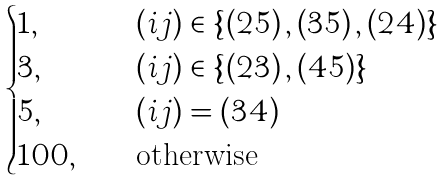<formula> <loc_0><loc_0><loc_500><loc_500>\begin{cases} 1 , & \quad \left ( i j \right ) \in \left \{ \left ( 2 5 \right ) , \left ( 3 5 \right ) , \left ( 2 4 \right ) \right \} \\ 3 , & \quad \left ( i j \right ) \in \left \{ \left ( 2 3 \right ) , \left ( 4 5 \right ) \right \} \\ 5 , & \quad \left ( i j \right ) = \left ( 3 4 \right ) \\ 1 0 0 , & \quad \text {otherwise } \end{cases}</formula> 